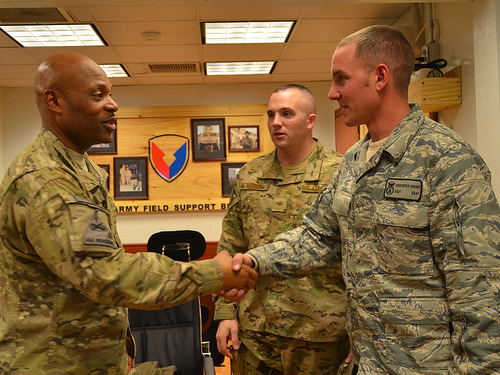<image>
Is the man one behind the man two? No. The man one is not behind the man two. From this viewpoint, the man one appears to be positioned elsewhere in the scene. 